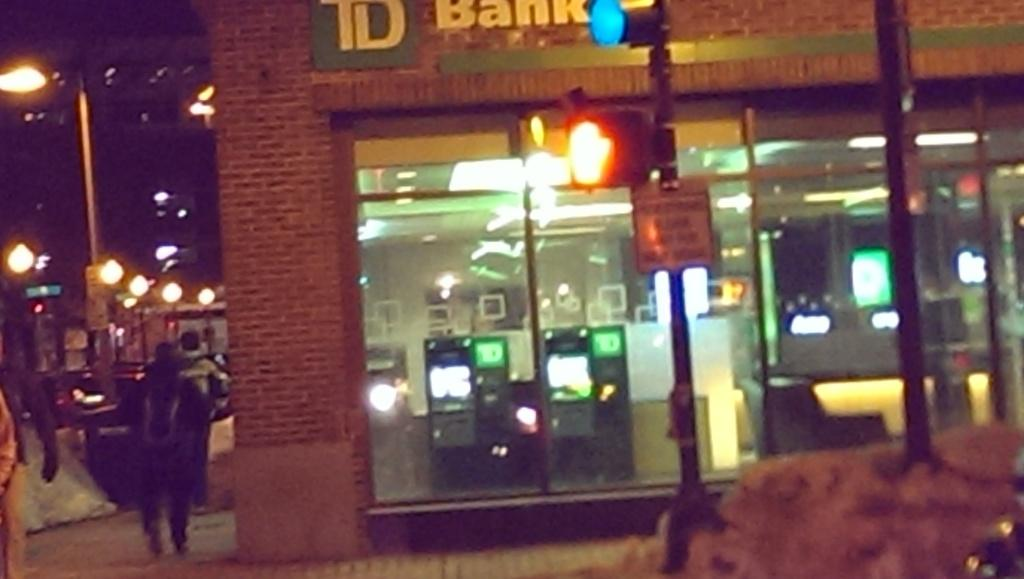What type of establishment is shown in the image? There is a store in the image. What type of lighting is visible in the image? Electric lights are visible in the image. What feature is present in the store that might be used for reflection? Mirrors are present in the image. What structural elements can be seen in the image? There are walls in the image. What type of signage is present in the image? An information board is in the image. What type of vertical structures are visible in the image? Street poles are visible in the image. What type of lighting is present on these poles? Street lights are present in the image. Are there any people visible in the image? Yes, there are persons on the road in the image. What type of cabbage is being sold in the store in the image? There is no cabbage visible in the image, and it is not mentioned that the store sells cabbage. What caused the hall to collapse in the image? There is no hall present in the image, and no collapse is mentioned or depicted. 